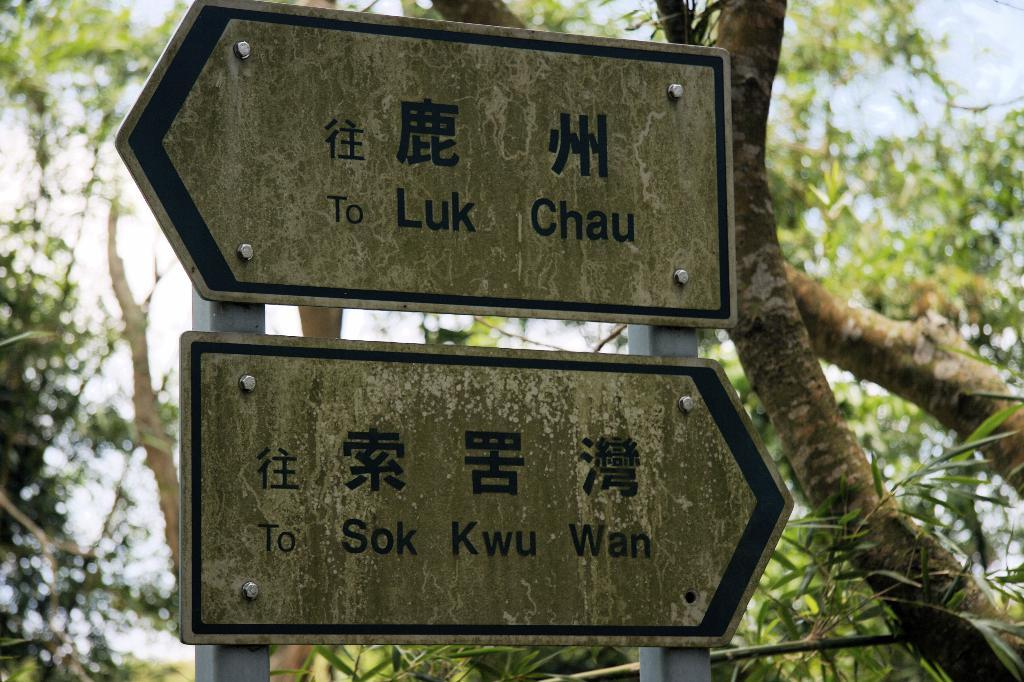What can be seen on the sign boards in the image? The information on the sign boards is not visible in the image. What type of vegetation is present in the image? There are trees in the image. What is visible in the background of the image? The sky is visible in the image. How many legs can be seen on the cannon in the image? There is no cannon present in the image, so it is not possible to determine the number of legs. 